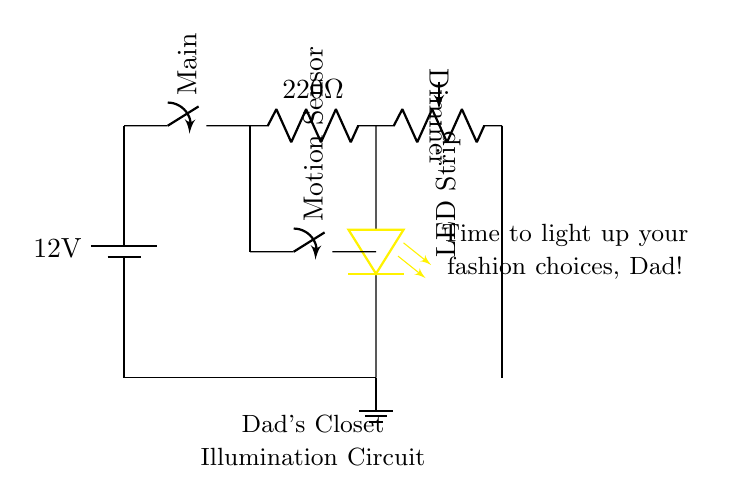What is the voltage of this circuit? The circuit diagram shows a battery labeled as 12V, indicating the voltage supplied to the circuit. Since it's directly connected to the rest of the components, the entire circuit operates at this voltage.
Answer: 12V What type of switch is used to control the LED strip? The diagram contains a switch labeled as "Main," which is typically used to turn the circuit on or off. This switch controls the power flow to the LED strip.
Answer: Main switch How many resistors are present in the circuit? There is one resistor labeled as 220 Ohms in the circuit, which limits the current flowing to the LED strip to prevent damage.
Answer: One resistor What is the function of the motion sensor? The motion sensor is indicated in the diagram and is used to detect movement. When it senses motion, it acts as a switch, allowing current to flow to the LED strip and turning the lights on automatically.
Answer: Detects motion What component is used for dimming the LED strip? The circuit includes a component labeled as "Dimmer," which is a potentiometer that allows adjustment of the brightness of the LED strip by varying the resistance in the circuit.
Answer: Dimmer potentiometer What is the current-limiting resistor's value? The resistor shown in the circuit is labeled with a value of 220 Ohms, which serves to limit the current flowing into the LED strip to prevent overheating.
Answer: 220 Ohms What is the purpose of the ground connection? The ground in the circuit serves as a reference point for the voltage in the circuit. It provides a return path for the current and is essential for the correct operation of all electrical systems.
Answer: Reference point 